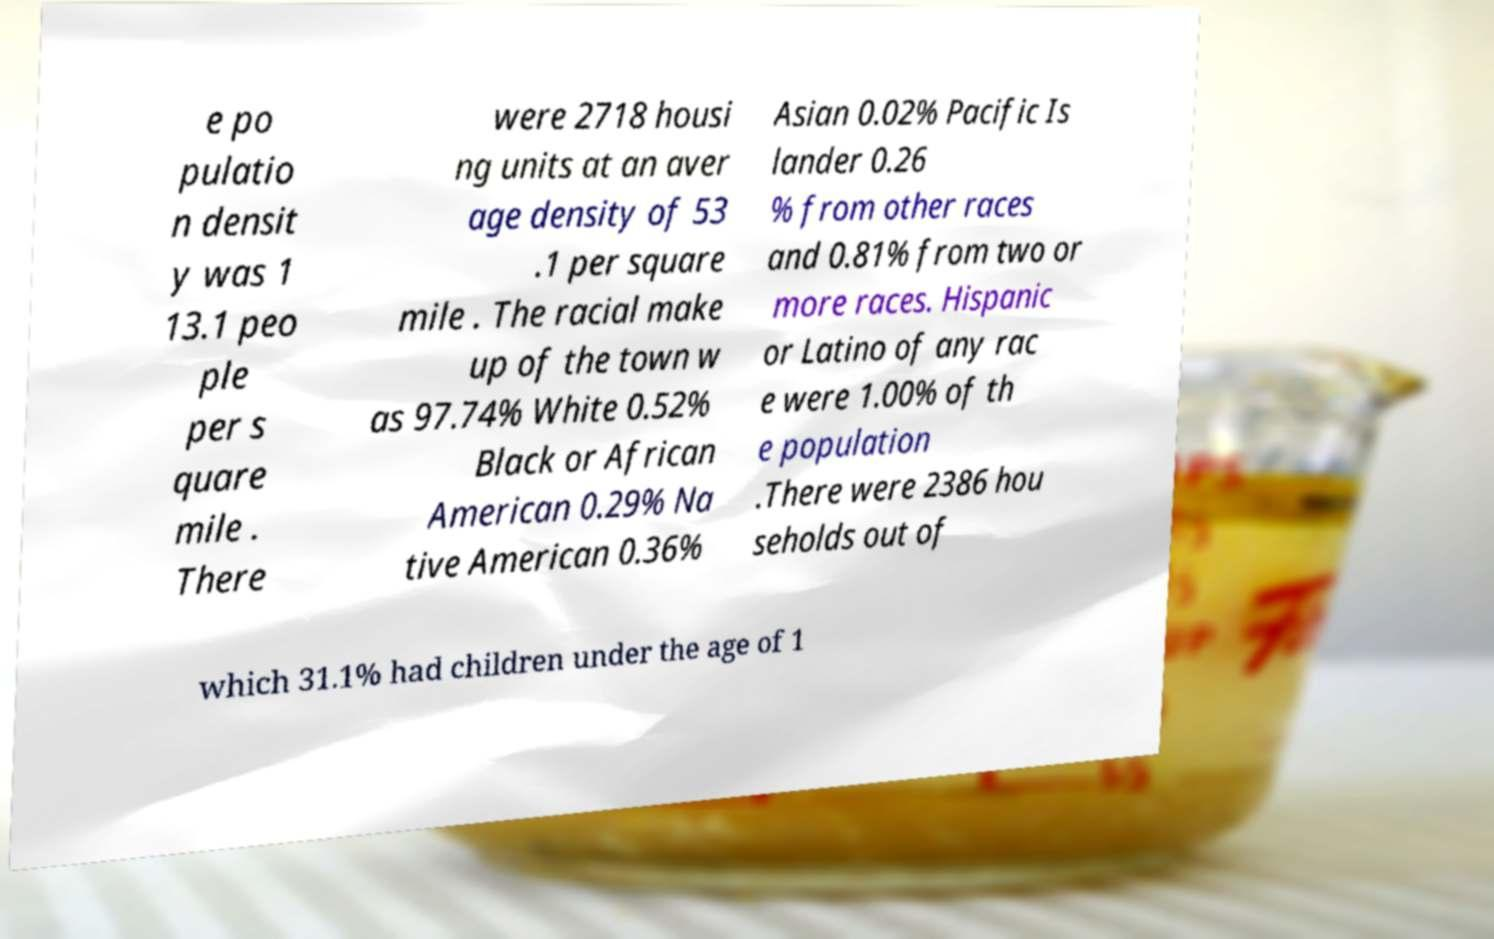Can you accurately transcribe the text from the provided image for me? e po pulatio n densit y was 1 13.1 peo ple per s quare mile . There were 2718 housi ng units at an aver age density of 53 .1 per square mile . The racial make up of the town w as 97.74% White 0.52% Black or African American 0.29% Na tive American 0.36% Asian 0.02% Pacific Is lander 0.26 % from other races and 0.81% from two or more races. Hispanic or Latino of any rac e were 1.00% of th e population .There were 2386 hou seholds out of which 31.1% had children under the age of 1 